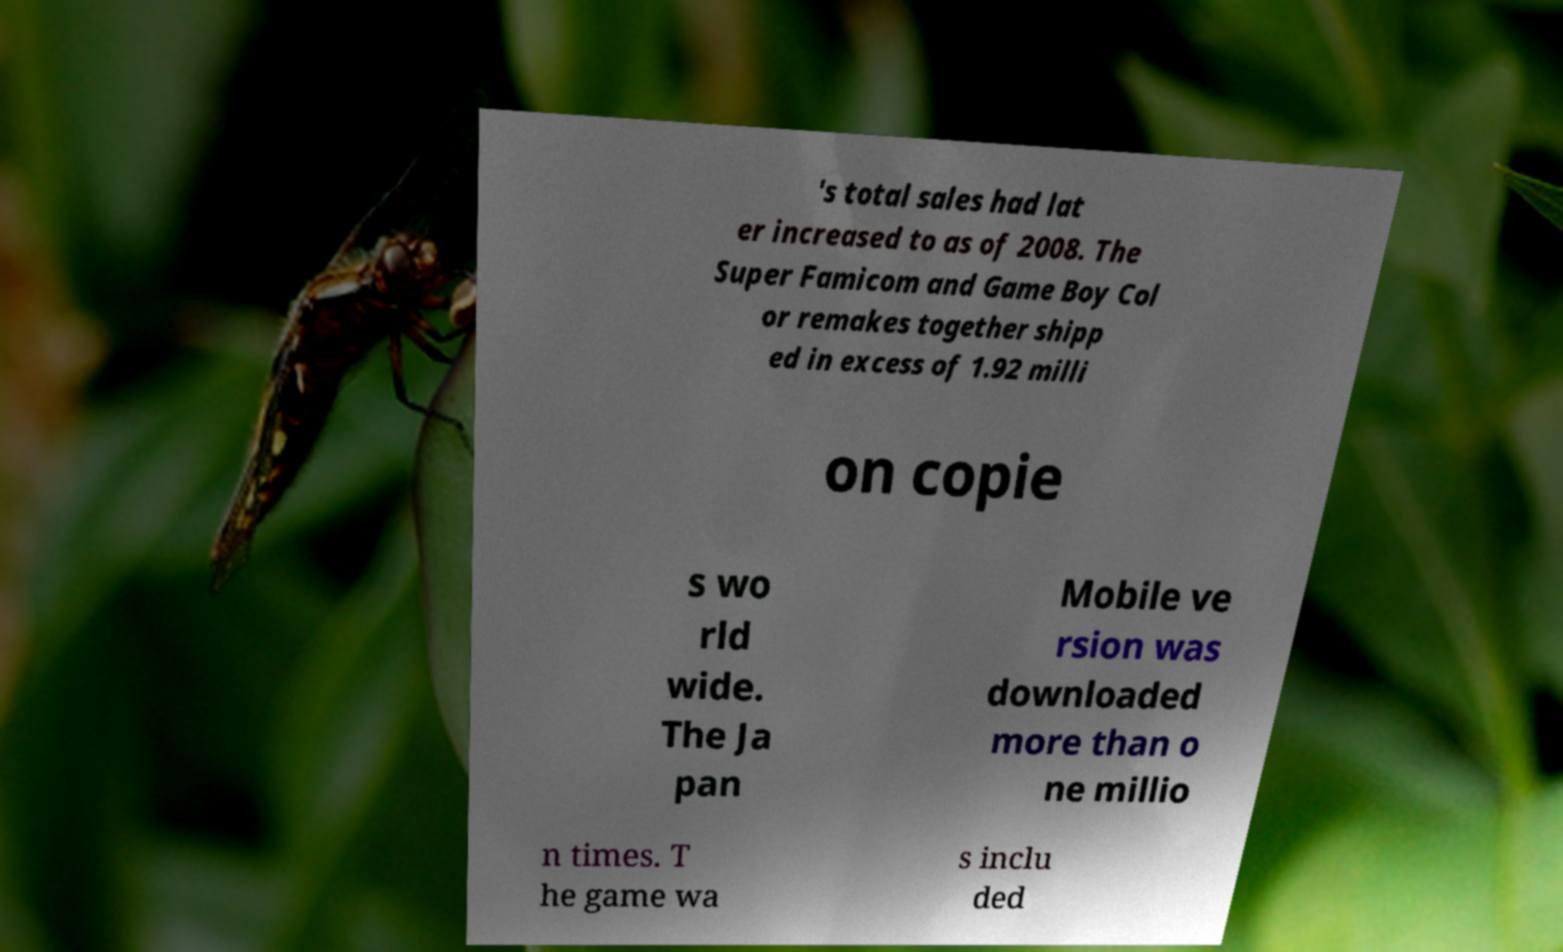Please read and relay the text visible in this image. What does it say? 's total sales had lat er increased to as of 2008. The Super Famicom and Game Boy Col or remakes together shipp ed in excess of 1.92 milli on copie s wo rld wide. The Ja pan Mobile ve rsion was downloaded more than o ne millio n times. T he game wa s inclu ded 